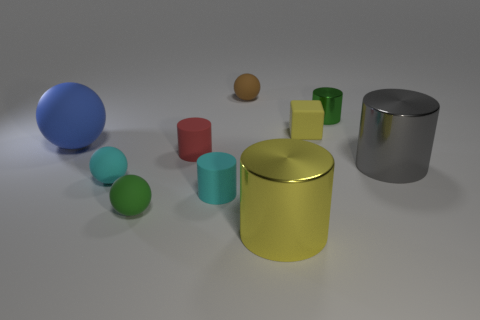There is a tiny metal object; is it the same color as the rubber object that is behind the yellow rubber cube?
Your response must be concise. No. Is the number of gray spheres greater than the number of large gray things?
Offer a very short reply. No. What color is the rubber block?
Your answer should be compact. Yellow. Is the color of the small cylinder right of the tiny brown rubber object the same as the cube?
Make the answer very short. No. There is a large object that is the same color as the cube; what is its material?
Offer a terse response. Metal. How many cubes have the same color as the large ball?
Your answer should be very brief. 0. There is a yellow thing behind the small red thing; does it have the same shape as the big gray object?
Your answer should be compact. No. Are there fewer large yellow objects on the left side of the large gray cylinder than yellow rubber things that are in front of the blue rubber sphere?
Keep it short and to the point. No. What material is the large thing left of the tiny red rubber object?
Give a very brief answer. Rubber. There is a object that is the same color as the tiny cube; what is its size?
Make the answer very short. Large. 